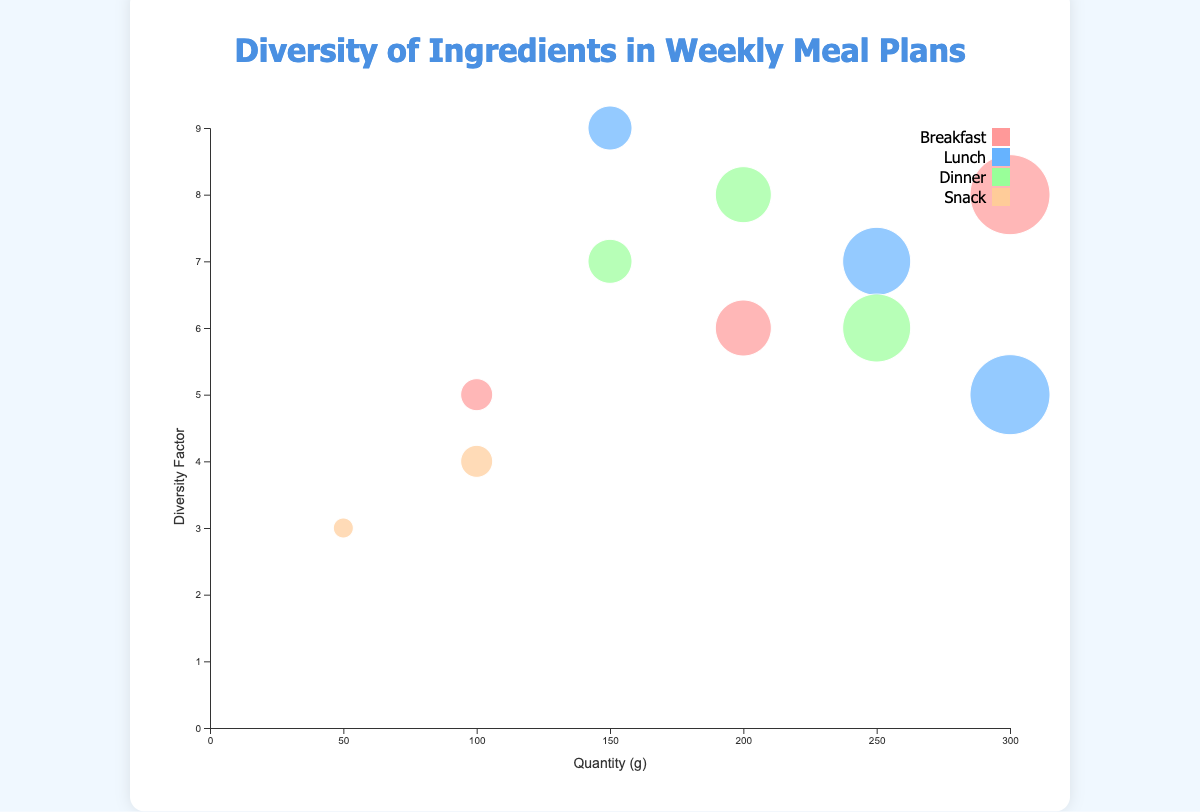What is the title of the figure? The title is prominently displayed at the top of the chart area, it reads "Diversity of Ingredients in Weekly Meal Plans".
Answer: Diversity of Ingredients in Weekly Meal Plans How many meal categories are represented in the bubble chart? There are four unique colors in the legend, each representing a different meal category: Breakfast, Lunch, Dinner, and Snack.
Answer: Four Which ingredient used in Lunch has the highest diversity factor? Looking at the y-axis for Lunch meal category, the ingredient with the highest point on the y-axis is Spinach, which has a diversity factor of 9.
Answer: Spinach What is the relationship between quantity and diversity factor for Oats? Referencing the position of the bubble for Oats, it's relatively high on the y-axis with a diversity factor of 8 and located towards the higher end on the x-axis with a quantity of 300g.
Answer: 300g, 8 Which meal category has ingredients with the highest diversity factor? Among the four meal categories, Lunch's highest diversity factor is for Spinach (9) which appears to be highest overall when compared to other categories.
Answer: Lunch If you sum the quantities of all the ingredients used for Dinner, what is the total? The quantities for Dinner are Salmon (200g), Broccoli (150g), and Brown Rice (250g). Add these together: 200 + 150 + 250 = 600g.
Answer: 600g Which ingredient has the smallest quantity, and what is its associated meal and diversity factor? The smallest bubble in the chart represents Almonds with a quantity of 50g. It is associated with the Snack category and has a diversity factor of 3.
Answer: Almonds, Snack, 3 How does the quantity of Blueberries compare to that of Greek Yogurt? The quantity of Blueberries is 100g and Greek Yogurt is also 100g. Both have the exact same quantity.
Answer: Equal Which meal category is represented by the color #ff9999? According to the legend, the color #ff9999 represents the Breakfast meal category.
Answer: Breakfast Among the ingredients for Breakfast, which one has the highest quantity, and what is its diversity factor? Oats have the highest quantity among Breakfast ingredients at 300g and a diversity factor of 8.
Answer: Oats, 300g, 8 